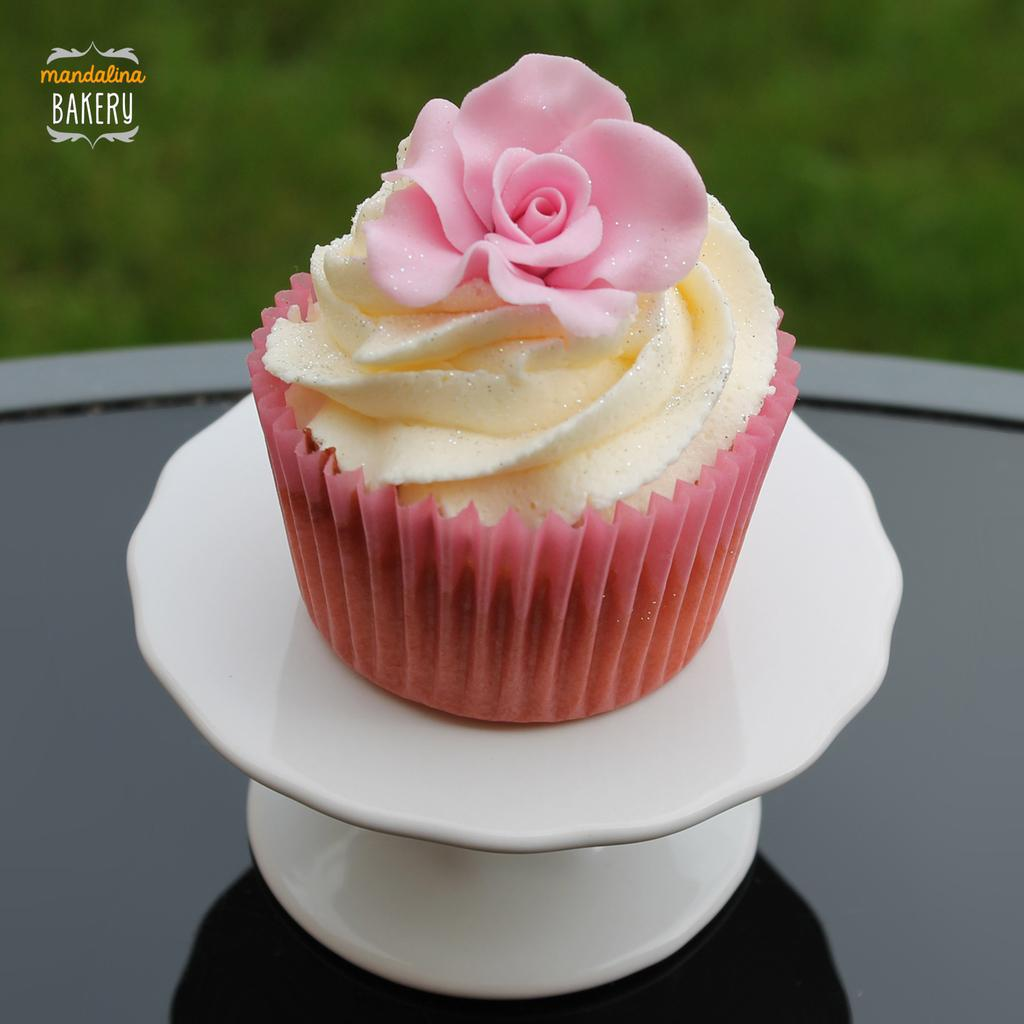What type of dessert is in the image? There is a cupcake in the image. How is the cupcake displayed or presented? The cupcake is on a white stand. What color is the rose in the image? The rose in the image is pink. What color is the background of the image? The background of the image is green. Where is the library located in the image? There is no library present in the image. What type of creature is interacting with the cupcake in the image? There is no creature present in the image; it only features a cupcake, a white stand, a pink rose, and a green background. 